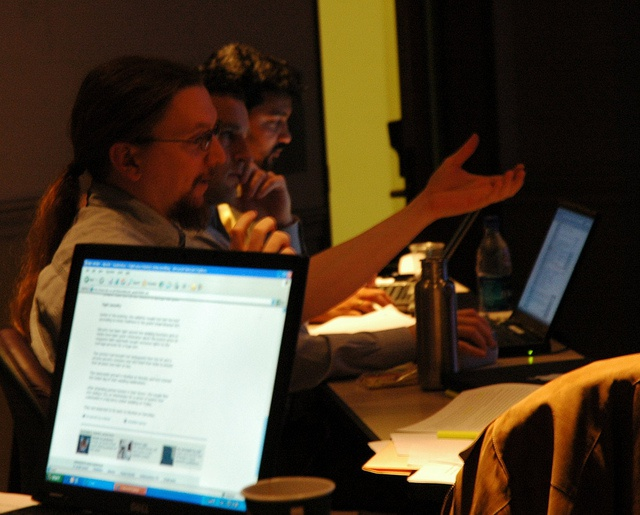Describe the objects in this image and their specific colors. I can see laptop in black, ivory, lightblue, and gray tones, people in black, maroon, and brown tones, chair in black, orange, brown, and maroon tones, laptop in black, gray, and blue tones, and people in black, maroon, brown, and gray tones in this image. 